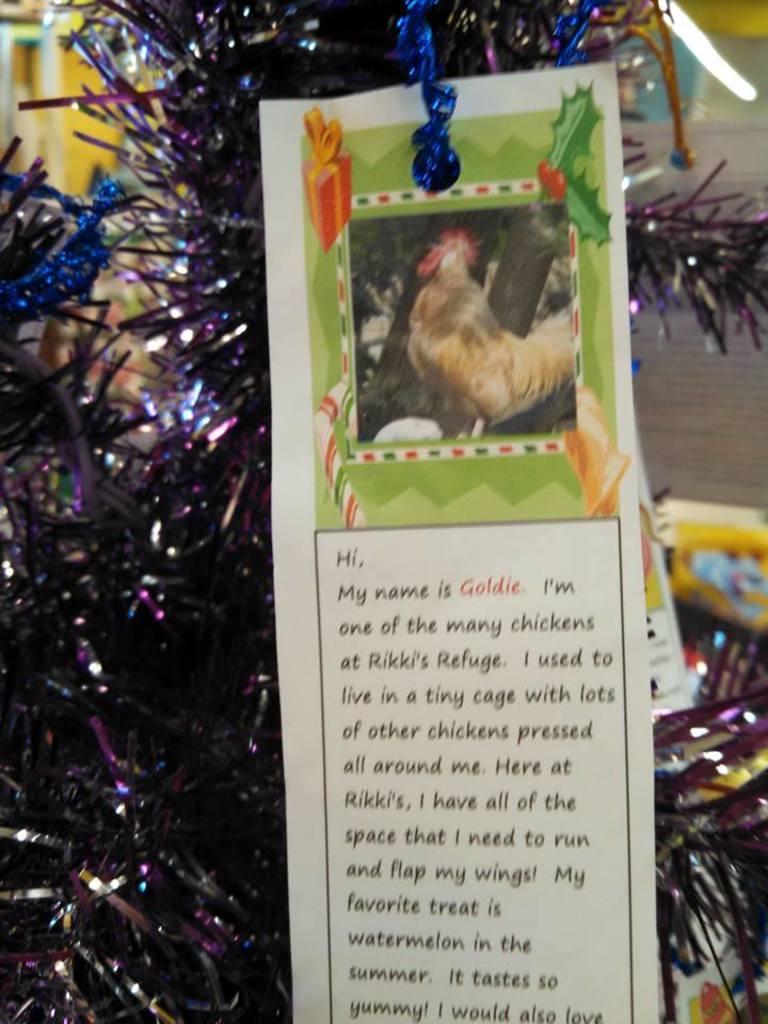What is the main subject in the center of the picture? There is a poster in the center of the picture. What can be found on the poster? The poster contains text and features a hen. What other elements are present in the picture? There are decorative items in the picture. How would you describe the background of the image? The background of the image is blurred. How many curves can be seen on the pail in the image? There is no pail present in the image, so it is not possible to determine the number of curves on it. 